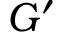<formula> <loc_0><loc_0><loc_500><loc_500>G ^ { \prime }</formula> 